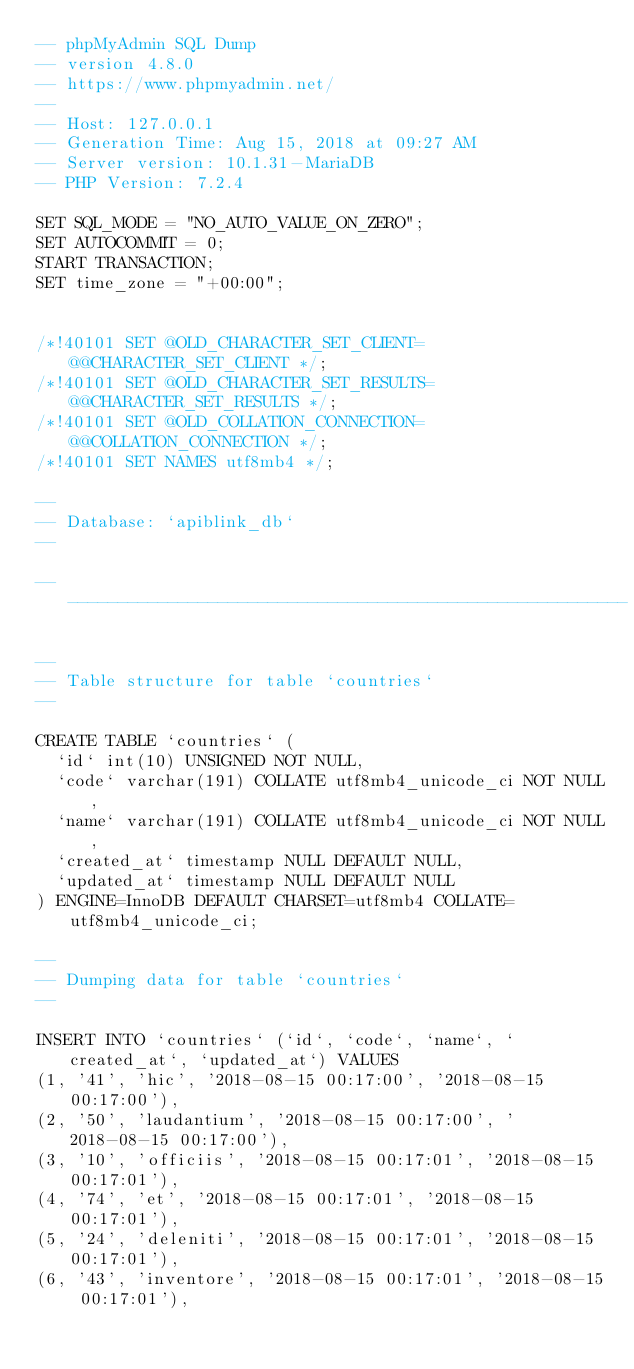<code> <loc_0><loc_0><loc_500><loc_500><_SQL_>-- phpMyAdmin SQL Dump
-- version 4.8.0
-- https://www.phpmyadmin.net/
--
-- Host: 127.0.0.1
-- Generation Time: Aug 15, 2018 at 09:27 AM
-- Server version: 10.1.31-MariaDB
-- PHP Version: 7.2.4

SET SQL_MODE = "NO_AUTO_VALUE_ON_ZERO";
SET AUTOCOMMIT = 0;
START TRANSACTION;
SET time_zone = "+00:00";


/*!40101 SET @OLD_CHARACTER_SET_CLIENT=@@CHARACTER_SET_CLIENT */;
/*!40101 SET @OLD_CHARACTER_SET_RESULTS=@@CHARACTER_SET_RESULTS */;
/*!40101 SET @OLD_COLLATION_CONNECTION=@@COLLATION_CONNECTION */;
/*!40101 SET NAMES utf8mb4 */;

--
-- Database: `apiblink_db`
--

-- --------------------------------------------------------

--
-- Table structure for table `countries`
--

CREATE TABLE `countries` (
  `id` int(10) UNSIGNED NOT NULL,
  `code` varchar(191) COLLATE utf8mb4_unicode_ci NOT NULL,
  `name` varchar(191) COLLATE utf8mb4_unicode_ci NOT NULL,
  `created_at` timestamp NULL DEFAULT NULL,
  `updated_at` timestamp NULL DEFAULT NULL
) ENGINE=InnoDB DEFAULT CHARSET=utf8mb4 COLLATE=utf8mb4_unicode_ci;

--
-- Dumping data for table `countries`
--

INSERT INTO `countries` (`id`, `code`, `name`, `created_at`, `updated_at`) VALUES
(1, '41', 'hic', '2018-08-15 00:17:00', '2018-08-15 00:17:00'),
(2, '50', 'laudantium', '2018-08-15 00:17:00', '2018-08-15 00:17:00'),
(3, '10', 'officiis', '2018-08-15 00:17:01', '2018-08-15 00:17:01'),
(4, '74', 'et', '2018-08-15 00:17:01', '2018-08-15 00:17:01'),
(5, '24', 'deleniti', '2018-08-15 00:17:01', '2018-08-15 00:17:01'),
(6, '43', 'inventore', '2018-08-15 00:17:01', '2018-08-15 00:17:01'),</code> 